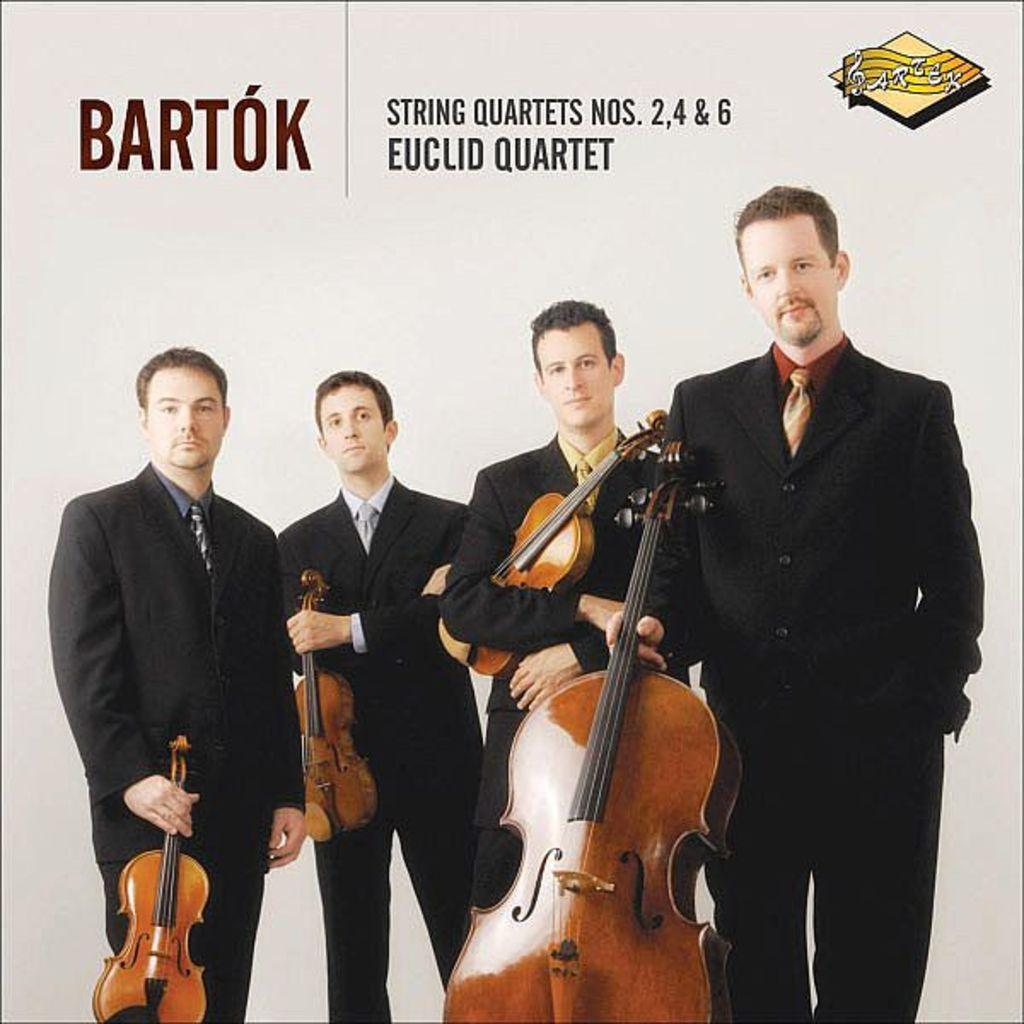How many people are in the image? There are four men in the image. What are the men wearing? The men are wearing black suits. What are the men doing in the image? The men are standing and holding guitars in their hands. What type of image is it? The image appears to be a poster. How many eyes can be seen on the men in the image? The number of eyes cannot be determined from the image, as it only shows the men from the waist up and does not provide a clear view of their faces. 